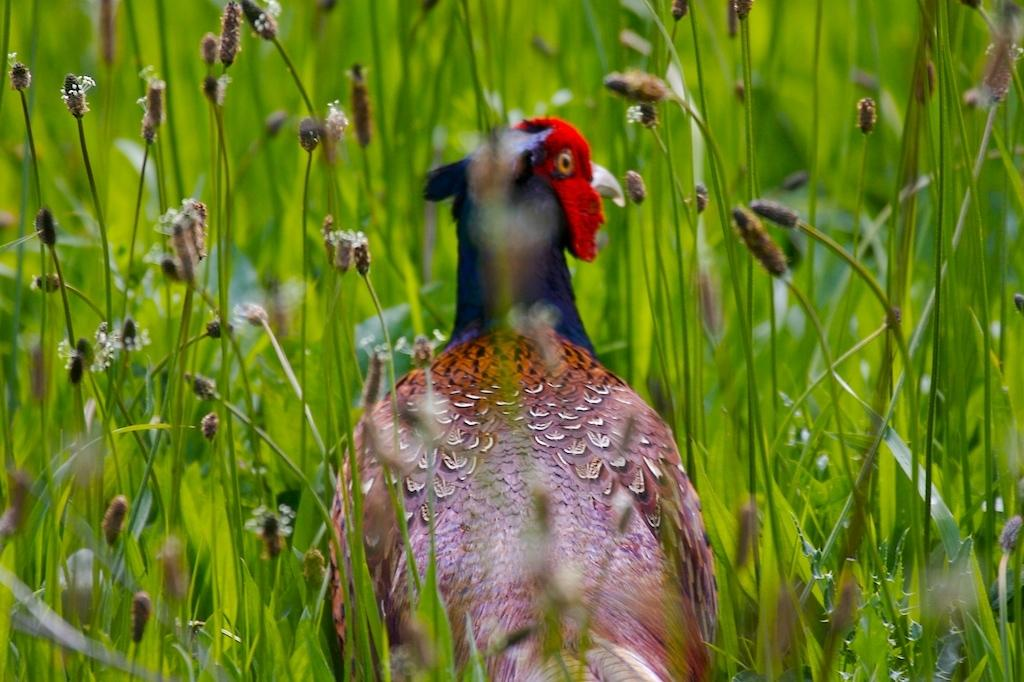What animal is the main subject of the picture? There is a turkey in the picture. What else can be seen in the picture besides the turkey? There are plants in the picture. How many cushions are present in the picture? There are no cushions present in the picture; it features a turkey and plants. What type of board can be seen in the picture? There is no board present in the picture. 